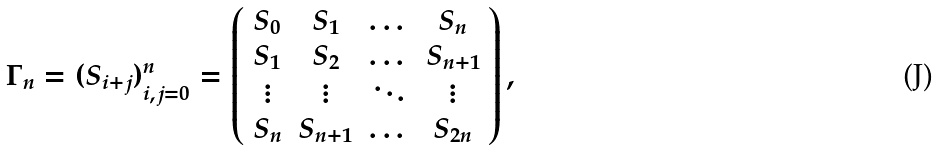Convert formula to latex. <formula><loc_0><loc_0><loc_500><loc_500>\Gamma _ { n } = ( S _ { i + j } ) _ { i , j = 0 } ^ { n } = \left ( \begin{array} { c c c c } S _ { 0 } & S _ { 1 } & \dots & S _ { n } \\ S _ { 1 } & S _ { 2 } & \dots & S _ { n + 1 } \\ \vdots & \vdots & \ddots & \vdots \\ S _ { n } & S _ { n + 1 } & \dots & S _ { 2 n } \end{array} \right ) ,</formula> 